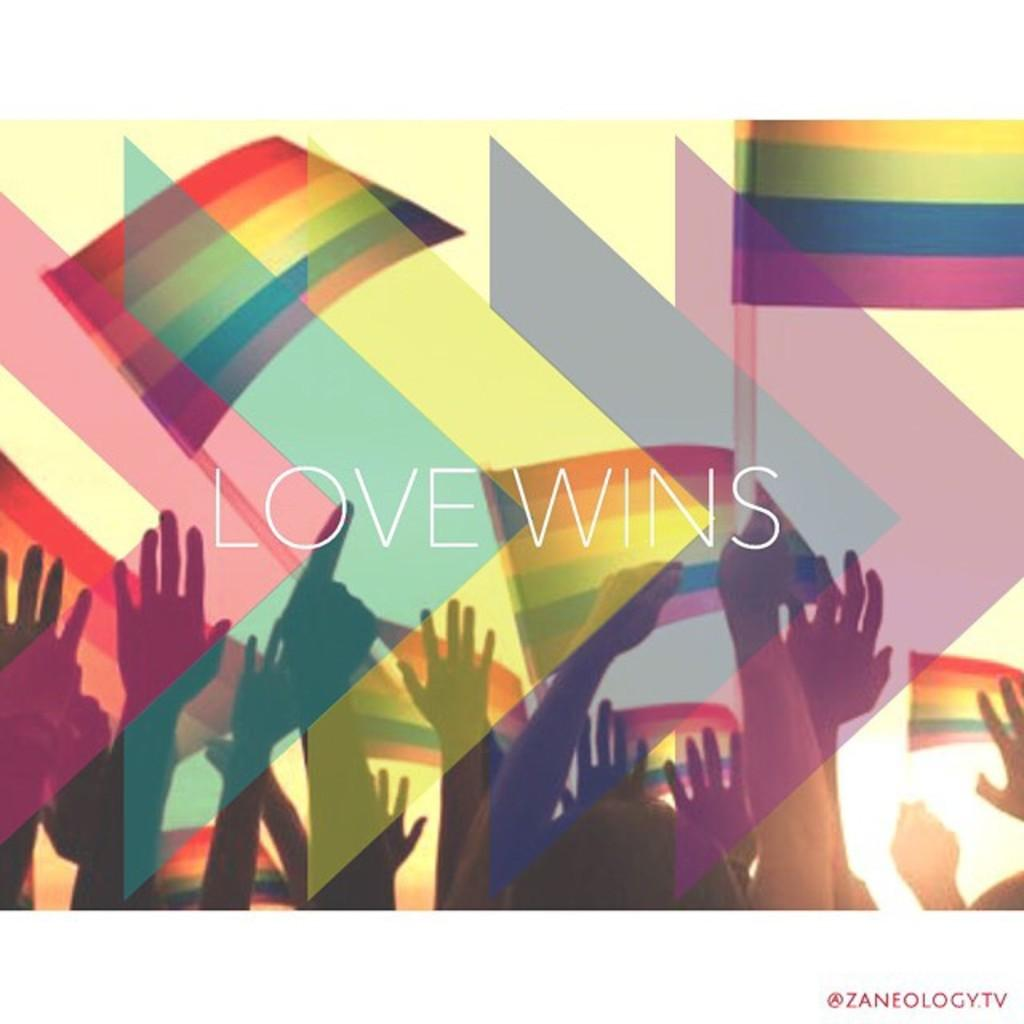What message is conveyed in the image? The phrase "love wins" is written on the image. What can be seen in the image besides the text? There are hands depicted in the image. How would you describe the background of the image? There are different colors in the background of the image. How many sticks are being held by the deer in the image? There are no sticks or deer present in the image. What type of quill is being used to write the phrase in the image? The image does not show a quill being used to write the phrase; it is likely written using a modern writing instrument or digitally created. 